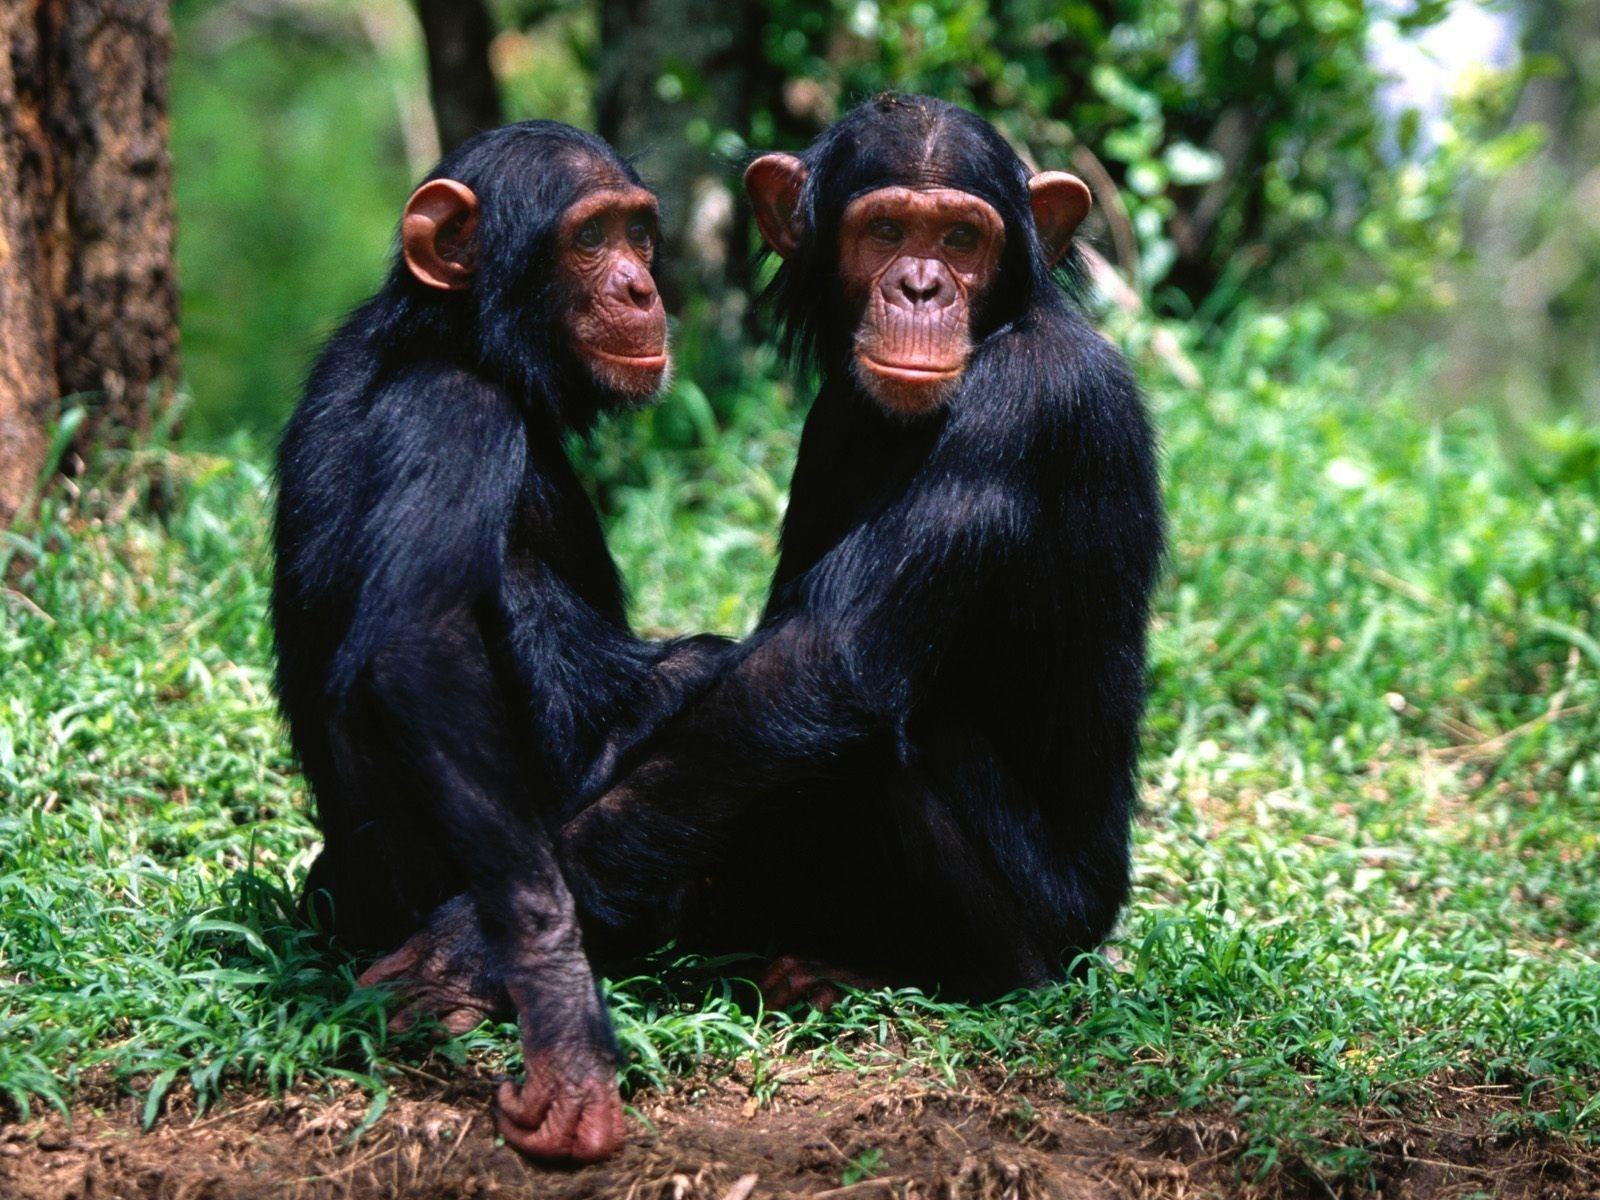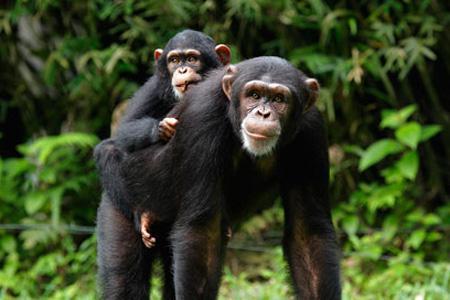The first image is the image on the left, the second image is the image on the right. Analyze the images presented: Is the assertion "a child ape is on its mothers back." valid? Answer yes or no. Yes. The first image is the image on the left, the second image is the image on the right. Given the left and right images, does the statement "A baby ape is riding it's mothers back." hold true? Answer yes or no. Yes. The first image is the image on the left, the second image is the image on the right. Examine the images to the left and right. Is the description "One of the images shows one monkey riding on the back of another monkey." accurate? Answer yes or no. Yes. 